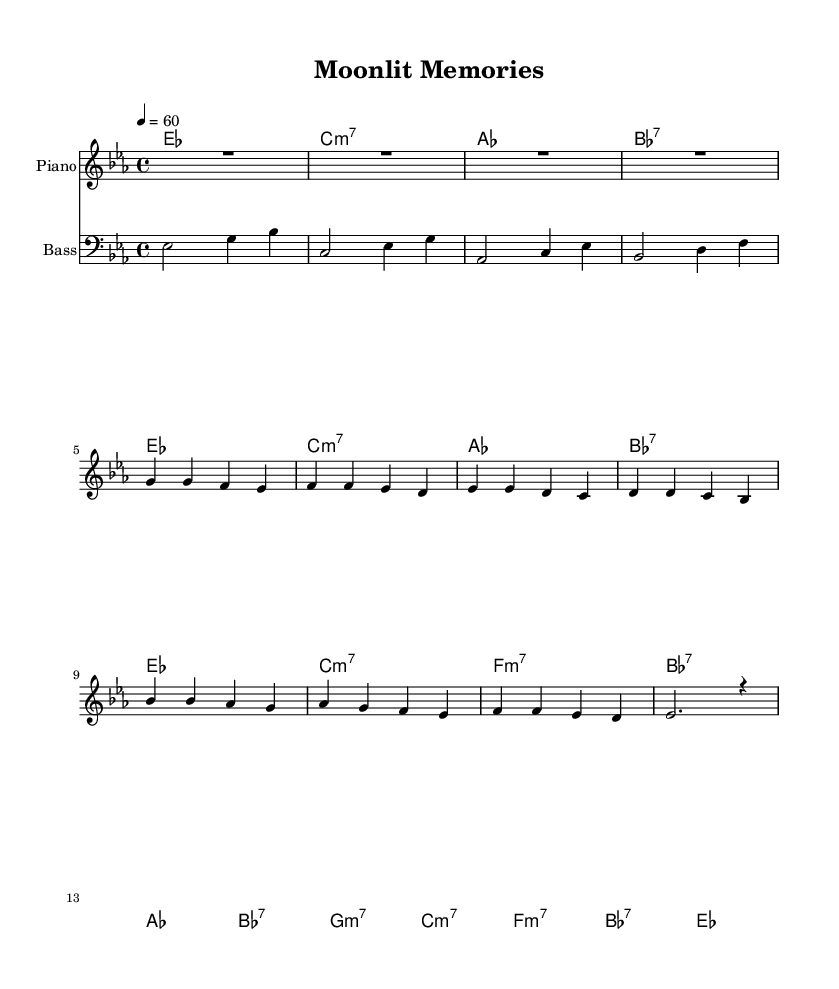What is the key signature of this music? The key signature displayed is E-flat major, which has three flats: B-flat, E-flat, and A-flat.
Answer: E-flat major What is the time signature of this piece? The time signature shown is 4/4, indicating there are four beats in each measure and the quarter note gets one beat.
Answer: 4/4 What is the tempo marking? The tempo marking indicates a pace of 60 beats per minute, meaning moderate speed for this rhythm and blues piece.
Answer: 60 What chords are used in the chorus? The chorus contains the following chords: A-flat major, B-flat seventh, G minor, and C major.
Answer: A-flat major, B-flat seventh, G minor, C major How many measures are there in the verse? Counting the individual lines of the verse section, there are four measures in total.
Answer: 4 What instrument is associated with the melody staff? The melody staff is labeled as "Piano," which is the instrument performing the melody line in this arrangement.
Answer: Piano What type of ballad is represented here? The music represents a smooth jazz-infused R&B ballad, a style marked by softened rhythms and heartfelt melodies typical of the genre in the 1970s and 1980s.
Answer: Smooth jazz-infused R&B ballad 